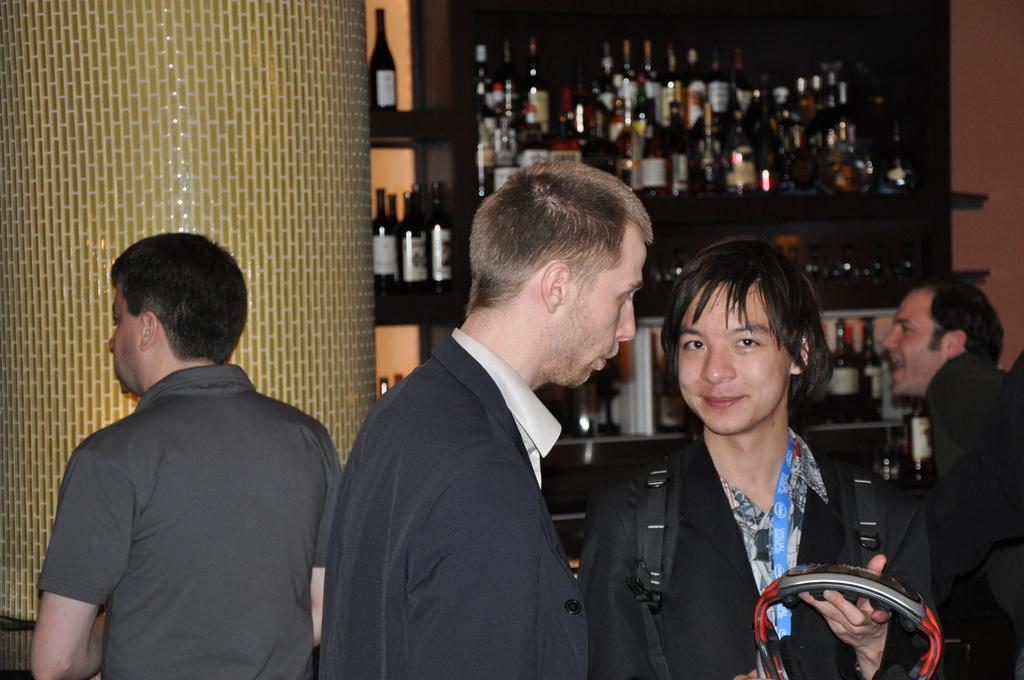Could you give a brief overview of what you see in this image? In this picture we can see a group of people where a person carrying a bag and holding an object and smiling and at the back of them we can see bottles. 